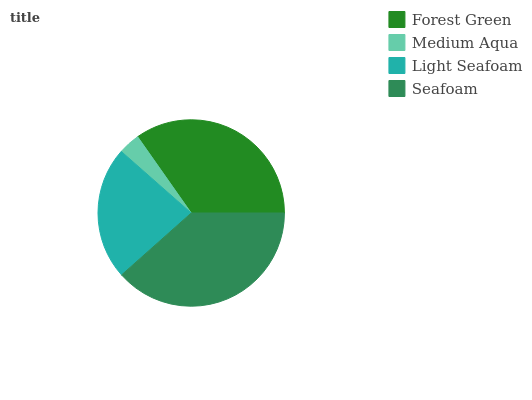Is Medium Aqua the minimum?
Answer yes or no. Yes. Is Seafoam the maximum?
Answer yes or no. Yes. Is Light Seafoam the minimum?
Answer yes or no. No. Is Light Seafoam the maximum?
Answer yes or no. No. Is Light Seafoam greater than Medium Aqua?
Answer yes or no. Yes. Is Medium Aqua less than Light Seafoam?
Answer yes or no. Yes. Is Medium Aqua greater than Light Seafoam?
Answer yes or no. No. Is Light Seafoam less than Medium Aqua?
Answer yes or no. No. Is Forest Green the high median?
Answer yes or no. Yes. Is Light Seafoam the low median?
Answer yes or no. Yes. Is Medium Aqua the high median?
Answer yes or no. No. Is Medium Aqua the low median?
Answer yes or no. No. 